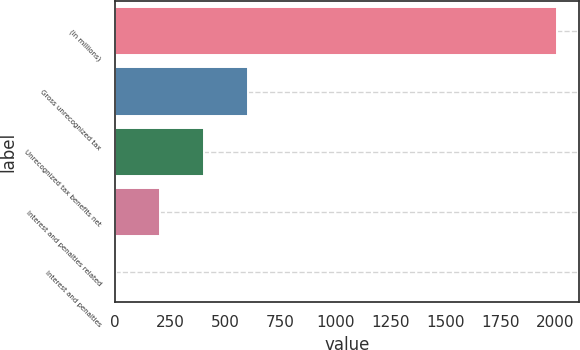Convert chart. <chart><loc_0><loc_0><loc_500><loc_500><bar_chart><fcel>(in millions)<fcel>Gross unrecognized tax<fcel>Unrecognized tax benefits net<fcel>Interest and penalties related<fcel>Interest and penalties<nl><fcel>2008<fcel>603.94<fcel>403.36<fcel>202.78<fcel>2.2<nl></chart> 